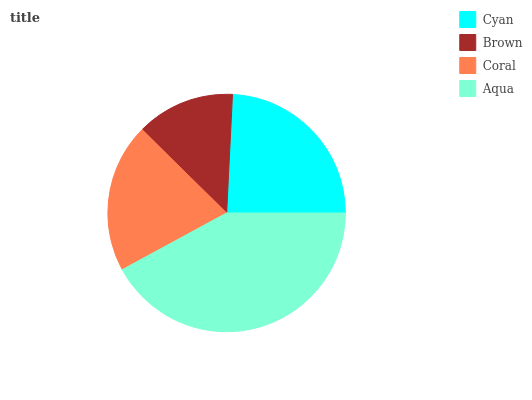Is Brown the minimum?
Answer yes or no. Yes. Is Aqua the maximum?
Answer yes or no. Yes. Is Coral the minimum?
Answer yes or no. No. Is Coral the maximum?
Answer yes or no. No. Is Coral greater than Brown?
Answer yes or no. Yes. Is Brown less than Coral?
Answer yes or no. Yes. Is Brown greater than Coral?
Answer yes or no. No. Is Coral less than Brown?
Answer yes or no. No. Is Cyan the high median?
Answer yes or no. Yes. Is Coral the low median?
Answer yes or no. Yes. Is Brown the high median?
Answer yes or no. No. Is Cyan the low median?
Answer yes or no. No. 